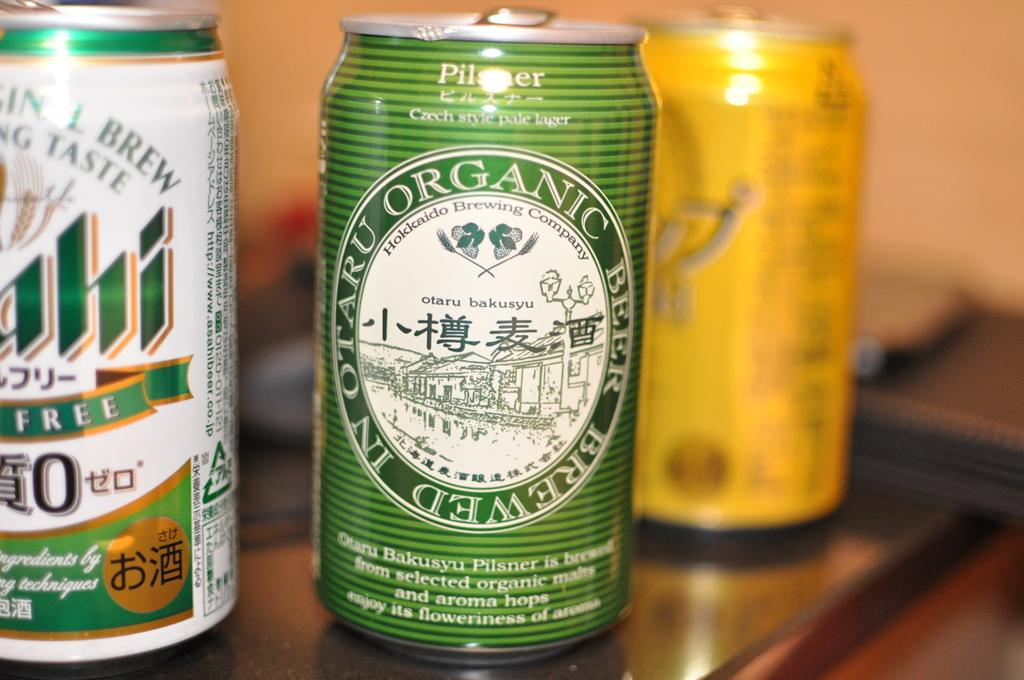<image>
Share a concise interpretation of the image provided. Cans of beer are sitting on a table with an organic pilsner being the first one 